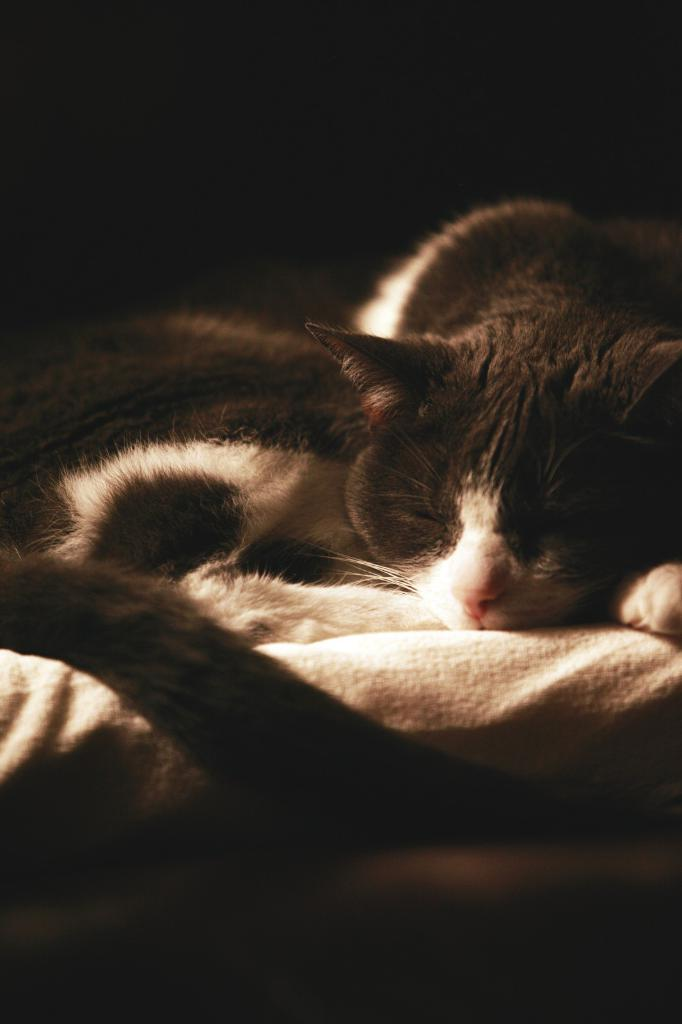What animal is present in the image? There is a cat in the image. Where is the cat located in the image? The cat is lying on a bed. Can you describe the lighting conditions in the image? The image may have been taken during the night. What type of army is depicted in the image? There is no army present in the image; it features a cat lying on a bed. How do the cows feel about the cat in the image? There are no cows present in the image, so their feelings cannot be determined. 